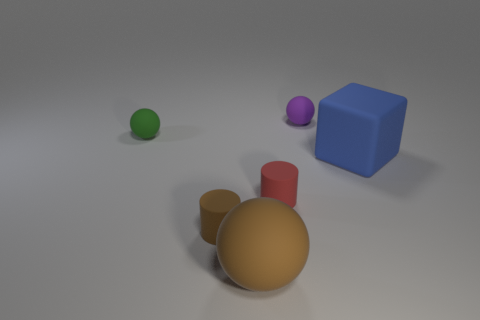Can you describe what the large gold-colored object in the front is sitting on? The large gold-colored object appears to be resting on a flat surface with a slightly reflective property, suggestive of a solid, smooth floor or platform. The way the light interacts with the surface indicates it is not textured, and the shadow cast by the object suggests that the lighting in the scene is coming from above. 